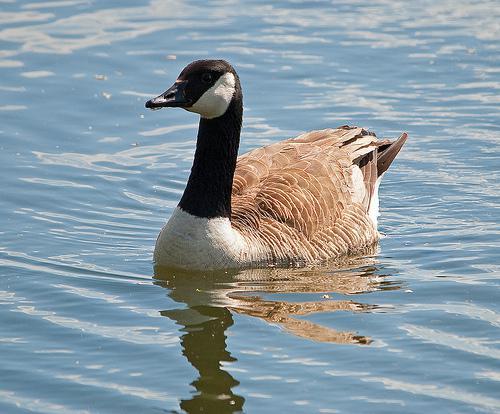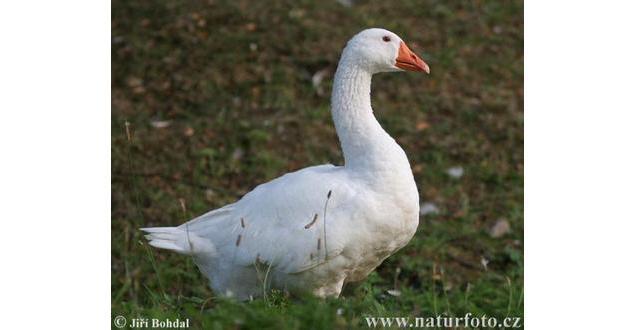The first image is the image on the left, the second image is the image on the right. Assess this claim about the two images: "In one of the images, a goose is flapping its wings while on the water". Correct or not? Answer yes or no. No. 